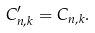<formula> <loc_0><loc_0><loc_500><loc_500>C ^ { \prime } _ { n , k } = C _ { n , k } .</formula> 